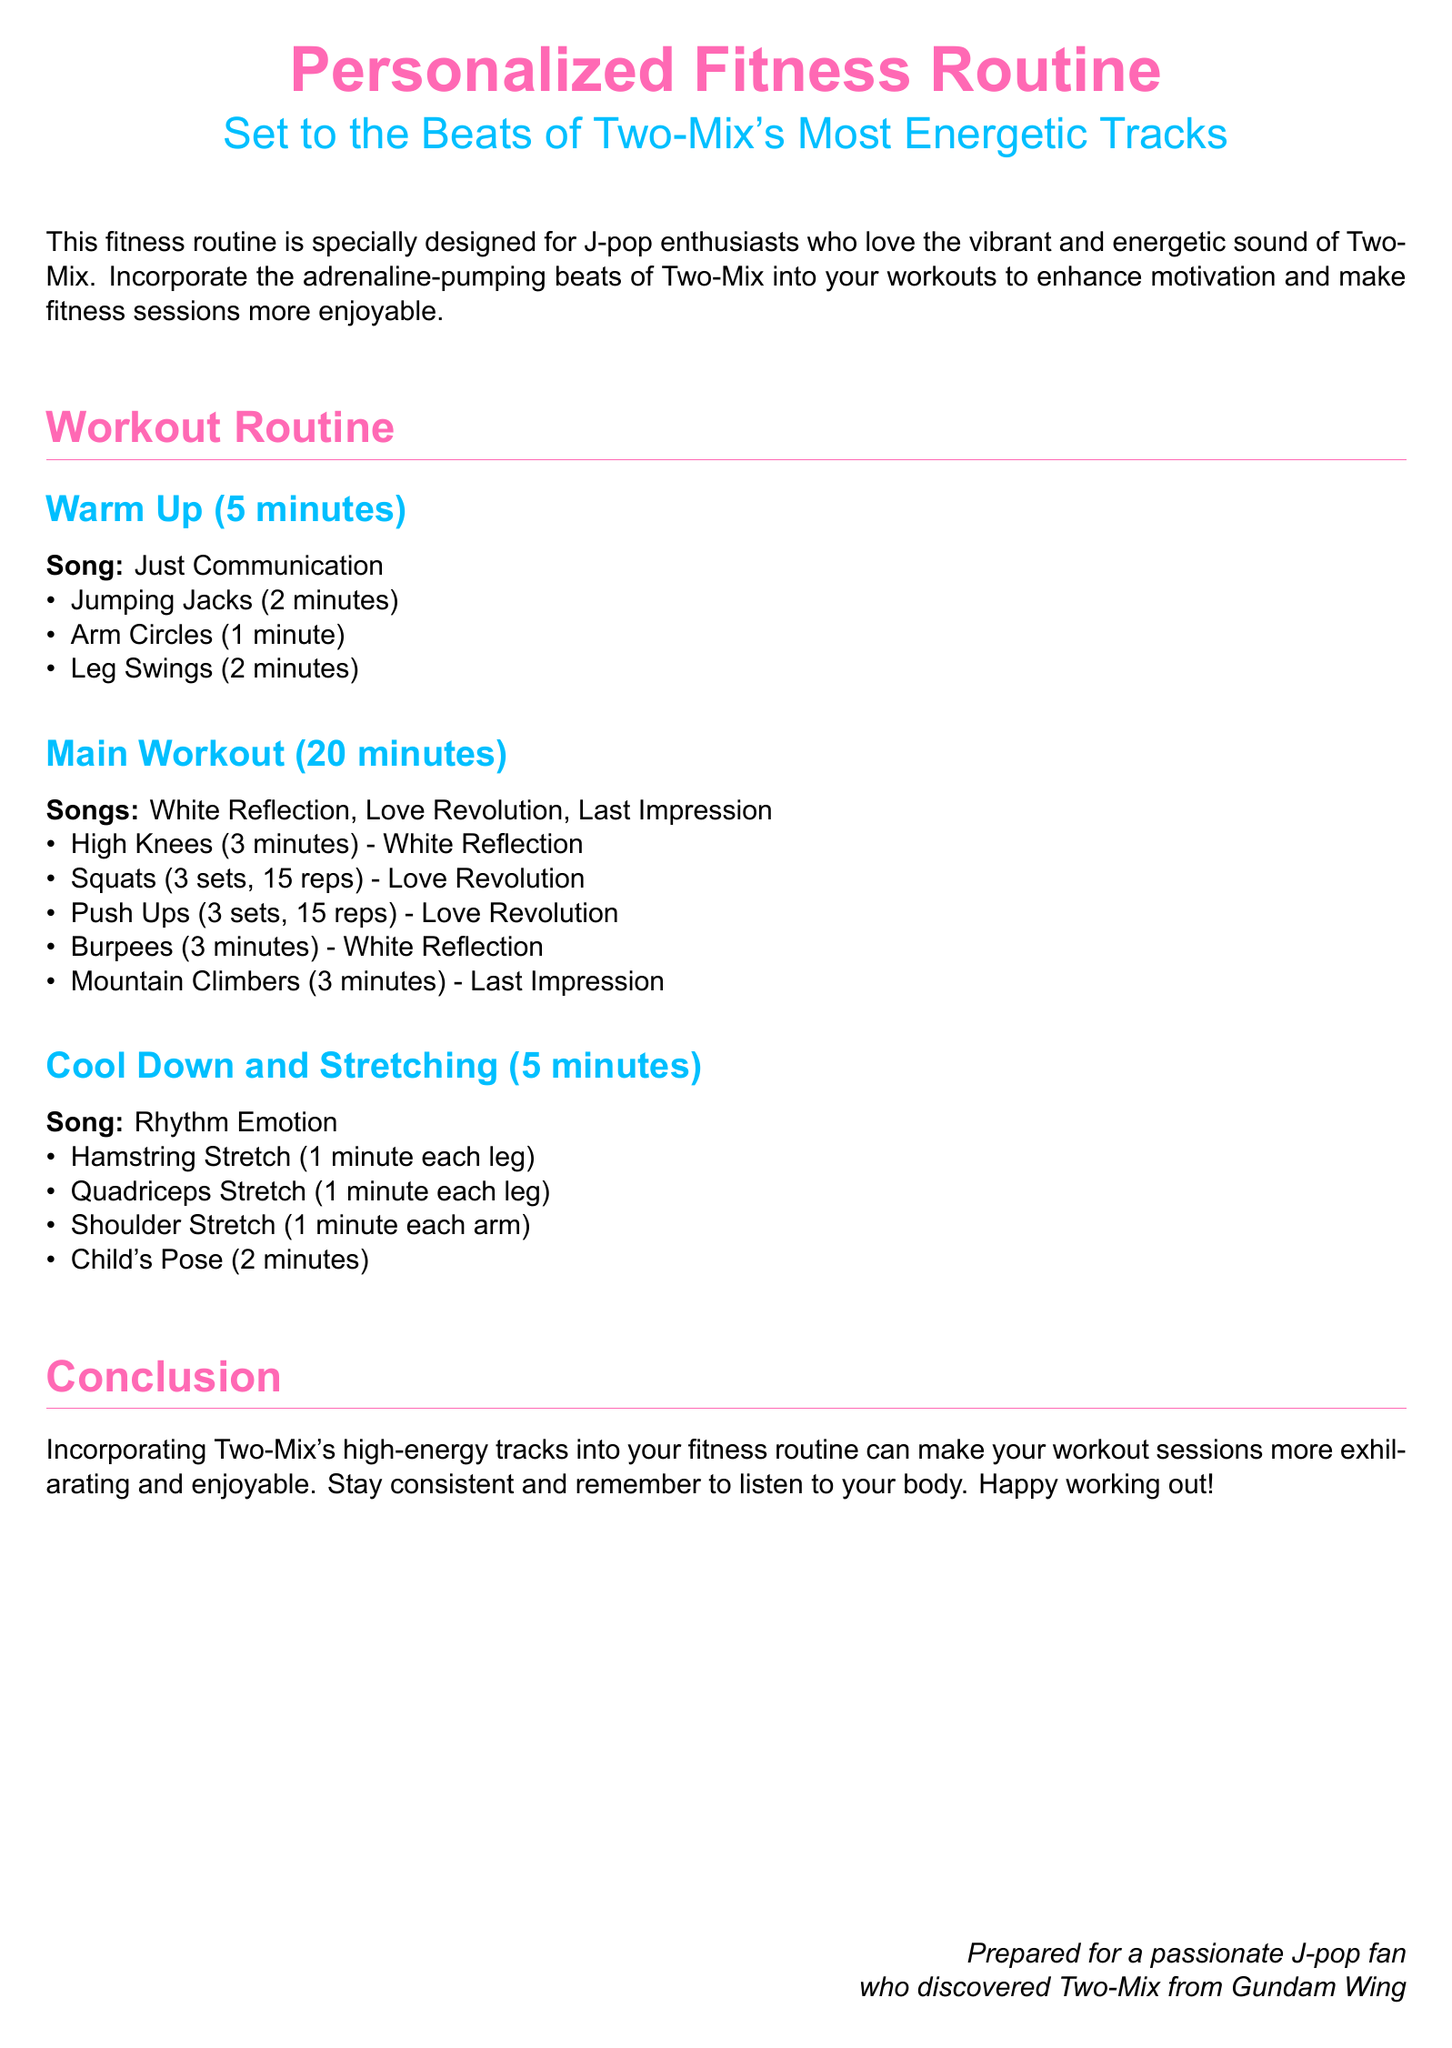what is the title of the document? The title is stated in the document's header section and indicates the purpose of the content.
Answer: Personalized Fitness Routine who is the target audience for this fitness routine? The document mentions that it is specially designed for a specific group of people who enjoy J-pop.
Answer: J-pop enthusiasts how long is the warm-up section? The warm-up duration is explicitly stated in the routine section of the document.
Answer: 5 minutes which song is suggested for the cool down? The song for the cool down is clearly mentioned in the section about stretching.
Answer: Rhythm Emotion how many songs are used in the main workout? The number of songs for the main workout is provided in the title of that section.
Answer: 3 songs what exercise is performed with "White Reflection"? The document mentions specific exercises linked to the songs used in the main workout.
Answer: High Knees what is the total number of repetitions for squats in the main workout? The document specifies the number of sets and repetitions for squats under the main workout section.
Answer: 45 reps what type of stretch is performed for the hamstrings? The stretching exercises are listed, detailing the type of stretches and their purpose.
Answer: Hamstring Stretch how many minutes is allocated for the main workout? The main workout duration is indicated at the beginning of that section in the document.
Answer: 20 minutes 